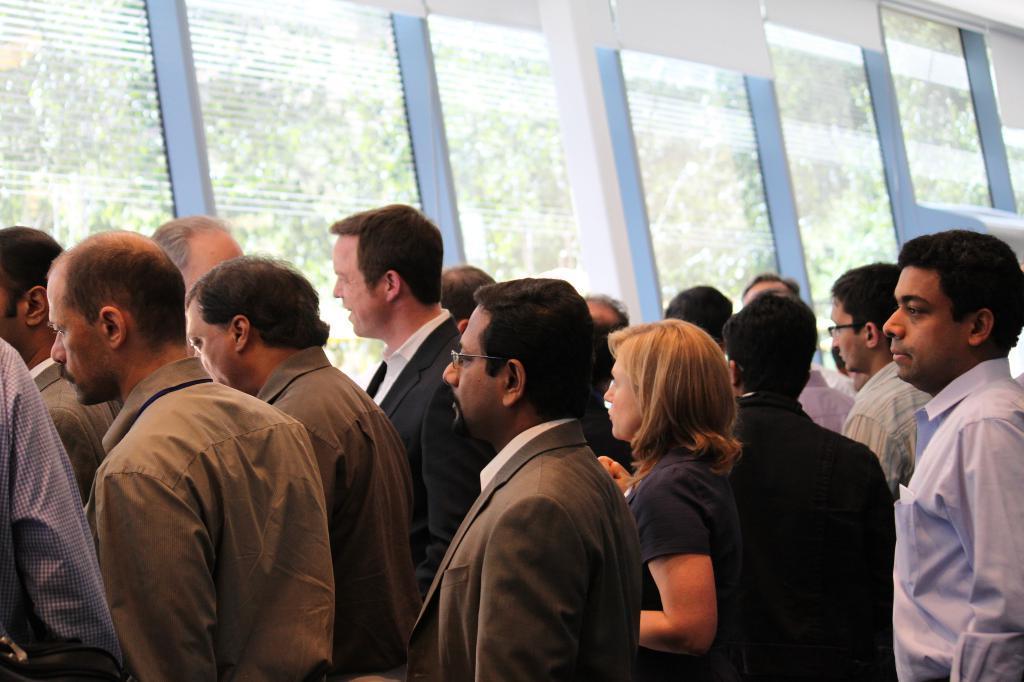In one or two sentences, can you explain what this image depicts? In this image there are a few people standing near the windows, outside the windows there are few trees and electric cables. 